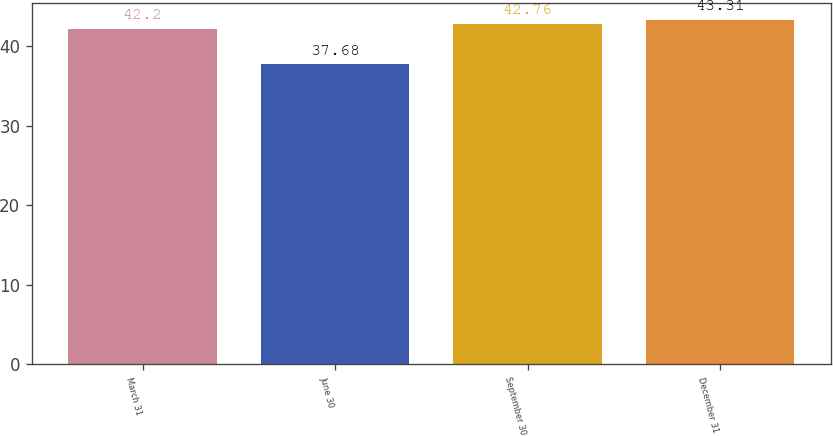Convert chart to OTSL. <chart><loc_0><loc_0><loc_500><loc_500><bar_chart><fcel>March 31<fcel>June 30<fcel>September 30<fcel>December 31<nl><fcel>42.2<fcel>37.68<fcel>42.76<fcel>43.31<nl></chart> 